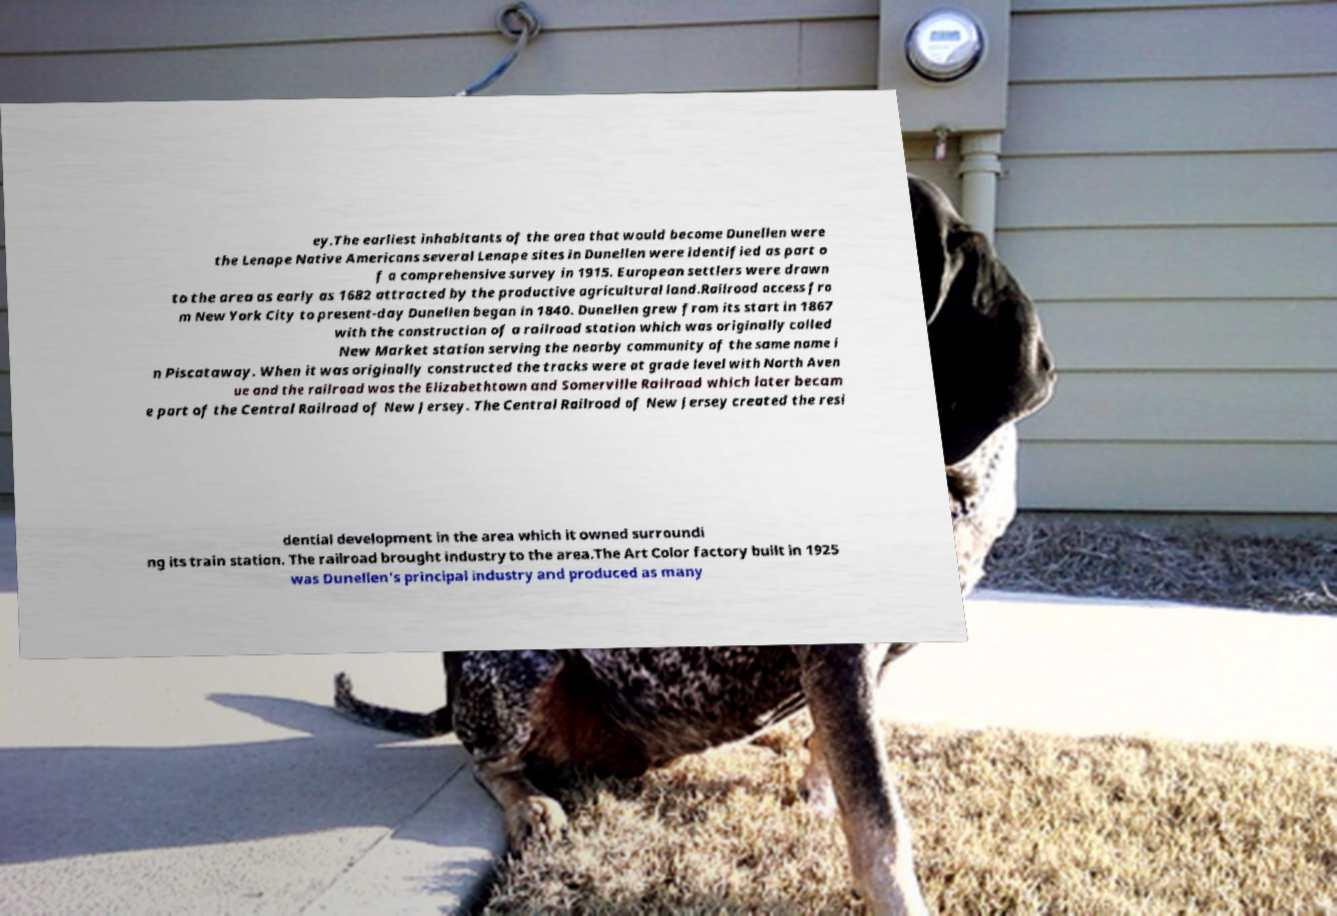What messages or text are displayed in this image? I need them in a readable, typed format. ey.The earliest inhabitants of the area that would become Dunellen were the Lenape Native Americans several Lenape sites in Dunellen were identified as part o f a comprehensive survey in 1915. European settlers were drawn to the area as early as 1682 attracted by the productive agricultural land.Railroad access fro m New York City to present-day Dunellen began in 1840. Dunellen grew from its start in 1867 with the construction of a railroad station which was originally called New Market station serving the nearby community of the same name i n Piscataway. When it was originally constructed the tracks were at grade level with North Aven ue and the railroad was the Elizabethtown and Somerville Railroad which later becam e part of the Central Railroad of New Jersey. The Central Railroad of New Jersey created the resi dential development in the area which it owned surroundi ng its train station. The railroad brought industry to the area.The Art Color factory built in 1925 was Dunellen's principal industry and produced as many 